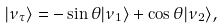<formula> <loc_0><loc_0><loc_500><loc_500>| \nu _ { \tau } \rangle = - \sin \theta | \nu _ { 1 } \rangle + \cos \theta | \nu _ { 2 } \rangle ,</formula> 